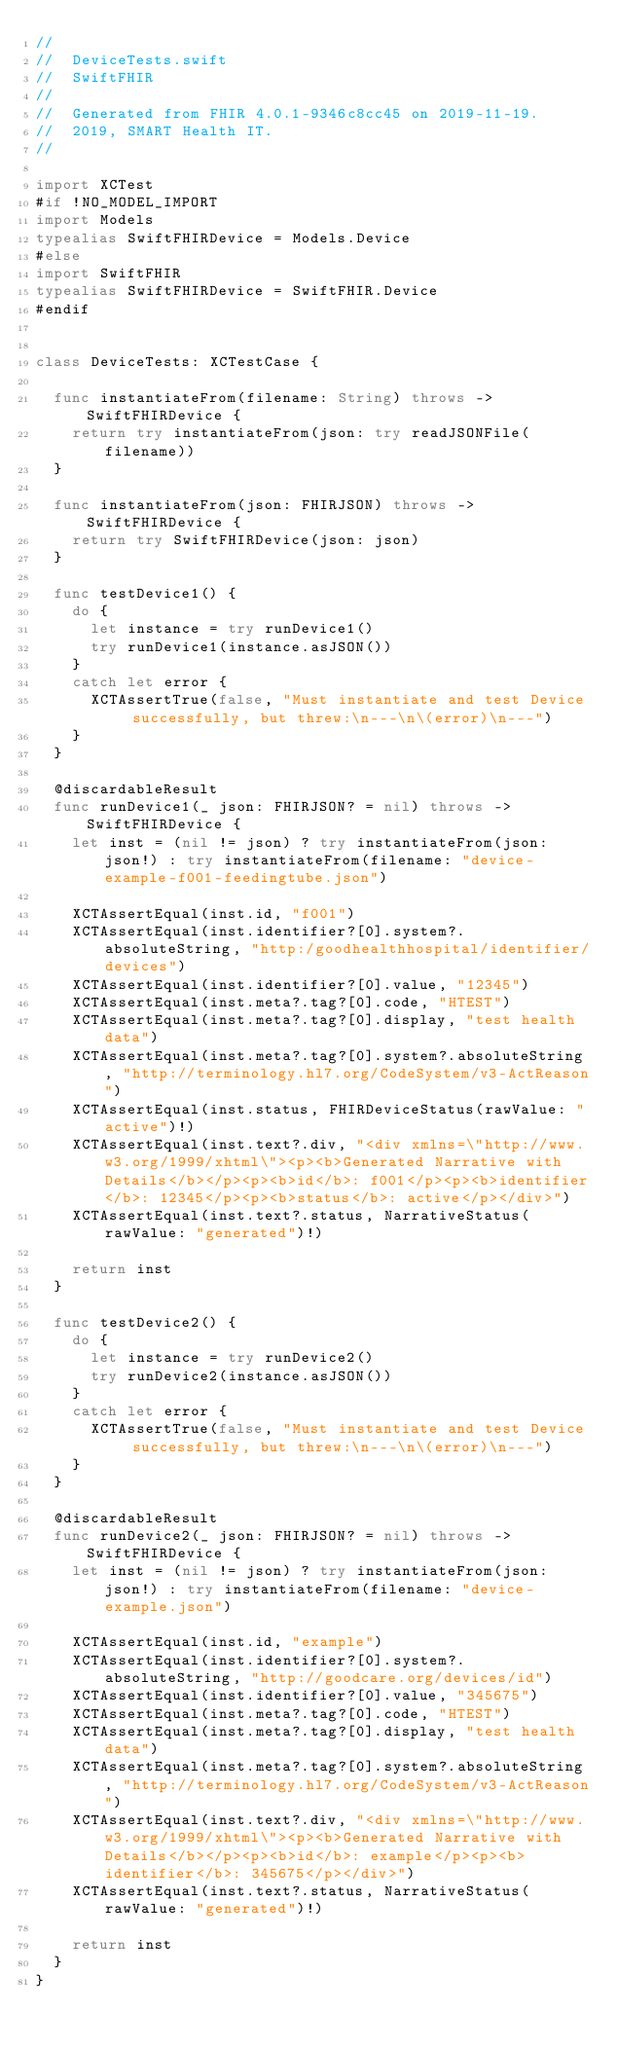Convert code to text. <code><loc_0><loc_0><loc_500><loc_500><_Swift_>//
//  DeviceTests.swift
//  SwiftFHIR
//
//  Generated from FHIR 4.0.1-9346c8cc45 on 2019-11-19.
//  2019, SMART Health IT.
//

import XCTest
#if !NO_MODEL_IMPORT
import Models
typealias SwiftFHIRDevice = Models.Device
#else
import SwiftFHIR
typealias SwiftFHIRDevice = SwiftFHIR.Device
#endif


class DeviceTests: XCTestCase {
	
	func instantiateFrom(filename: String) throws -> SwiftFHIRDevice {
		return try instantiateFrom(json: try readJSONFile(filename))
	}
	
	func instantiateFrom(json: FHIRJSON) throws -> SwiftFHIRDevice {
		return try SwiftFHIRDevice(json: json)
	}
	
	func testDevice1() {
		do {
			let instance = try runDevice1()
			try runDevice1(instance.asJSON())
		}
		catch let error {
			XCTAssertTrue(false, "Must instantiate and test Device successfully, but threw:\n---\n\(error)\n---")
		}
	}
	
	@discardableResult
	func runDevice1(_ json: FHIRJSON? = nil) throws -> SwiftFHIRDevice {
		let inst = (nil != json) ? try instantiateFrom(json: json!) : try instantiateFrom(filename: "device-example-f001-feedingtube.json")
		
		XCTAssertEqual(inst.id, "f001")
		XCTAssertEqual(inst.identifier?[0].system?.absoluteString, "http:/goodhealthhospital/identifier/devices")
		XCTAssertEqual(inst.identifier?[0].value, "12345")
		XCTAssertEqual(inst.meta?.tag?[0].code, "HTEST")
		XCTAssertEqual(inst.meta?.tag?[0].display, "test health data")
		XCTAssertEqual(inst.meta?.tag?[0].system?.absoluteString, "http://terminology.hl7.org/CodeSystem/v3-ActReason")
		XCTAssertEqual(inst.status, FHIRDeviceStatus(rawValue: "active")!)
		XCTAssertEqual(inst.text?.div, "<div xmlns=\"http://www.w3.org/1999/xhtml\"><p><b>Generated Narrative with Details</b></p><p><b>id</b>: f001</p><p><b>identifier</b>: 12345</p><p><b>status</b>: active</p></div>")
		XCTAssertEqual(inst.text?.status, NarrativeStatus(rawValue: "generated")!)
		
		return inst
	}
	
	func testDevice2() {
		do {
			let instance = try runDevice2()
			try runDevice2(instance.asJSON())
		}
		catch let error {
			XCTAssertTrue(false, "Must instantiate and test Device successfully, but threw:\n---\n\(error)\n---")
		}
	}
	
	@discardableResult
	func runDevice2(_ json: FHIRJSON? = nil) throws -> SwiftFHIRDevice {
		let inst = (nil != json) ? try instantiateFrom(json: json!) : try instantiateFrom(filename: "device-example.json")
		
		XCTAssertEqual(inst.id, "example")
		XCTAssertEqual(inst.identifier?[0].system?.absoluteString, "http://goodcare.org/devices/id")
		XCTAssertEqual(inst.identifier?[0].value, "345675")
		XCTAssertEqual(inst.meta?.tag?[0].code, "HTEST")
		XCTAssertEqual(inst.meta?.tag?[0].display, "test health data")
		XCTAssertEqual(inst.meta?.tag?[0].system?.absoluteString, "http://terminology.hl7.org/CodeSystem/v3-ActReason")
		XCTAssertEqual(inst.text?.div, "<div xmlns=\"http://www.w3.org/1999/xhtml\"><p><b>Generated Narrative with Details</b></p><p><b>id</b>: example</p><p><b>identifier</b>: 345675</p></div>")
		XCTAssertEqual(inst.text?.status, NarrativeStatus(rawValue: "generated")!)
		
		return inst
	}
}
</code> 